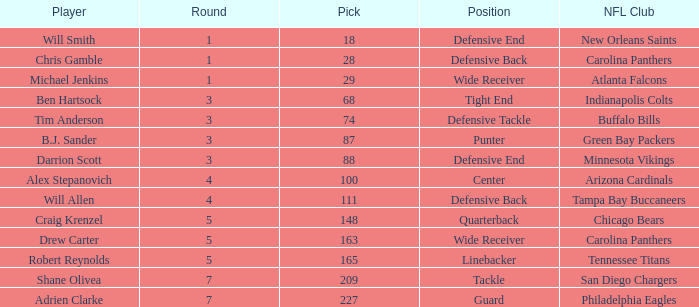What is the average Round number of Player Adrien Clarke? 7.0. 